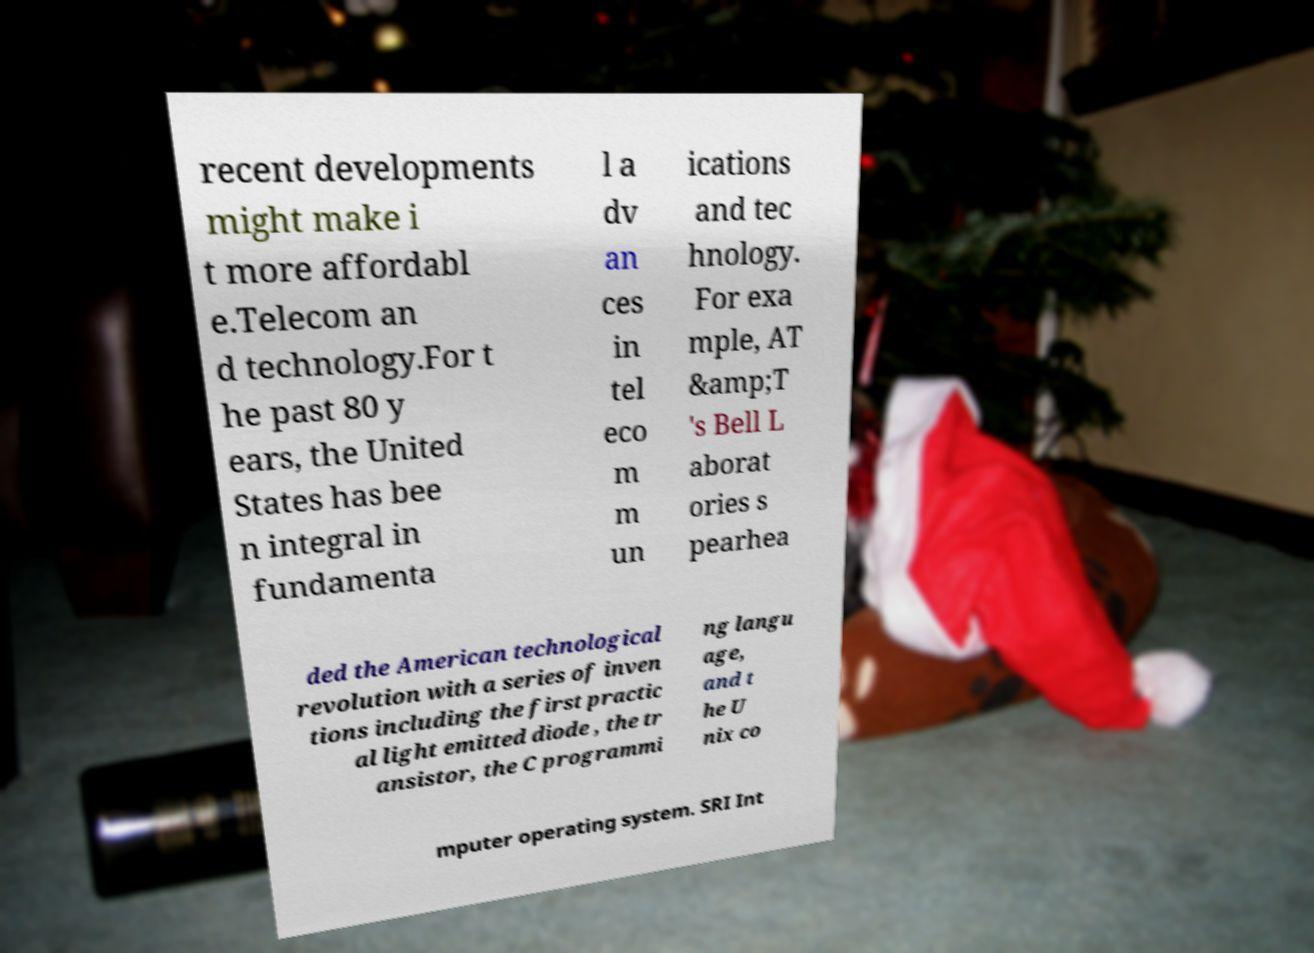Please read and relay the text visible in this image. What does it say? recent developments might make i t more affordabl e.Telecom an d technology.For t he past 80 y ears, the United States has bee n integral in fundamenta l a dv an ces in tel eco m m un ications and tec hnology. For exa mple, AT &amp;T 's Bell L aborat ories s pearhea ded the American technological revolution with a series of inven tions including the first practic al light emitted diode , the tr ansistor, the C programmi ng langu age, and t he U nix co mputer operating system. SRI Int 